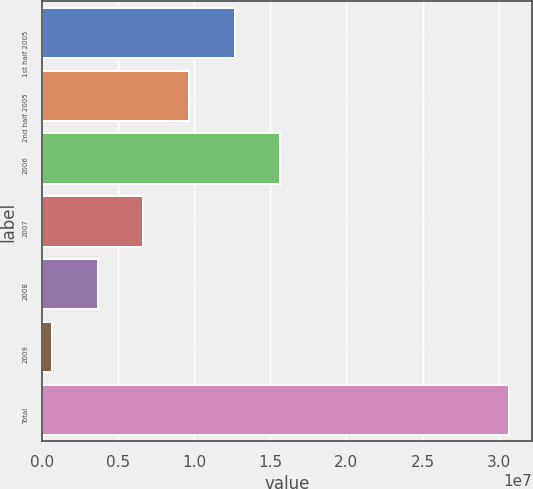<chart> <loc_0><loc_0><loc_500><loc_500><bar_chart><fcel>1st half 2005<fcel>2nd half 2005<fcel>2006<fcel>2007<fcel>2008<fcel>2009<fcel>Total<nl><fcel>1.26596e+07<fcel>9.6572e+06<fcel>1.5662e+07<fcel>6.6548e+06<fcel>3.6524e+06<fcel>650000<fcel>3.0674e+07<nl></chart> 